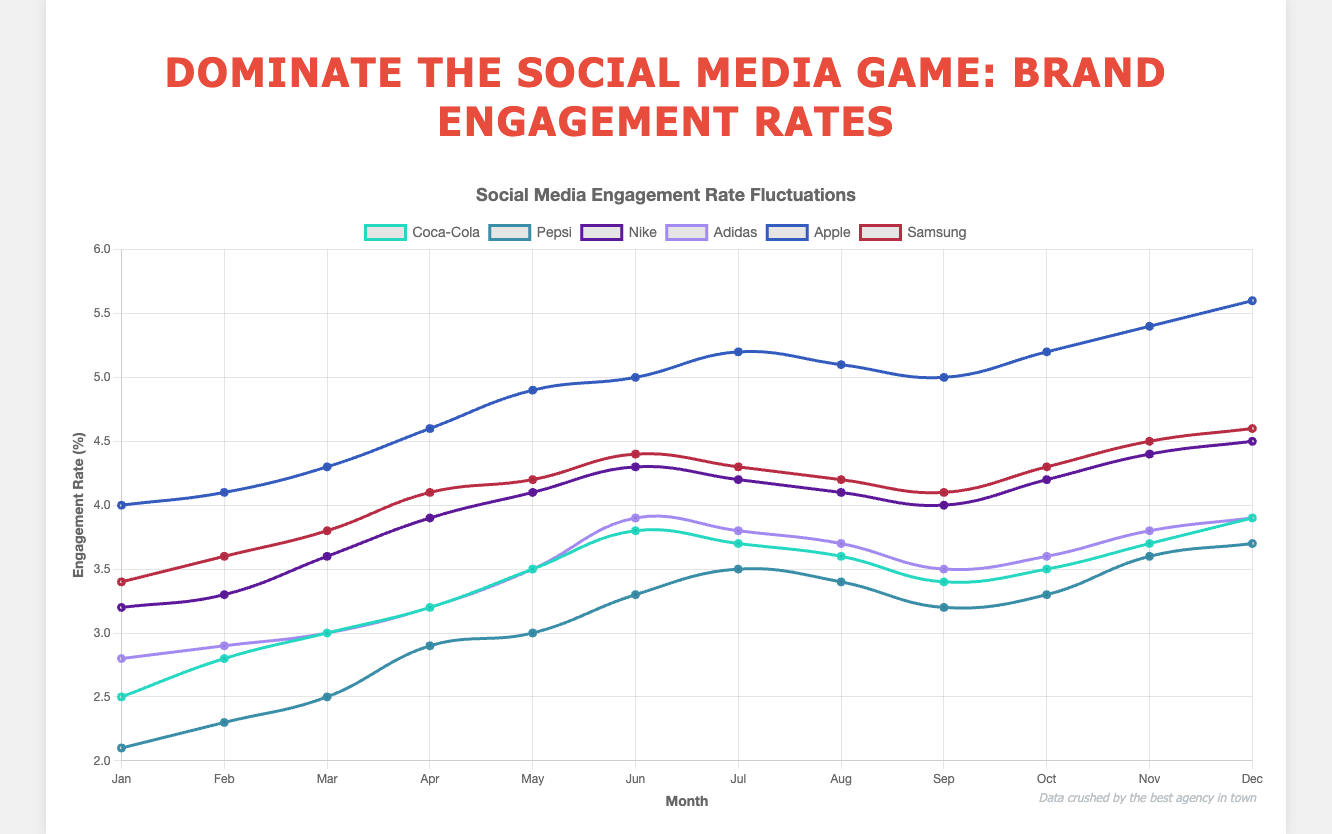Which brand has the highest engagement rate in December? In December, Apple has the highest engagement rate at 5.6%.
Answer: Apple How does Pepsi’s engagement rate in June compare to Coca-Cola’s engagement rate in June? Pepsi's engagement rate in June is 3.3%, while Coca-Cola's is 3.8%. So, Coca-Cola's rate is higher by 0.5%.
Answer: Coca-Cola is 0.5% higher Which brand has the most significant drop in engagement rate from July to August? By comparing the engagement rate drop from July to August across all brands, Nike shows a decrease from 4.2% to 4.1%, a drop of 0.1%. Pepsi drops from 3.5% to 3.4%, just 0.1%. Coca-Cola drops from 3.7% to 3.6%, also a 0.1% drop. Therefore, no brand has a significant drop; all have minor drops.
Answer: No significant drop What is the average engagement rate for Adidas over the year? Summing up the engagement rates for Adidas (2.8 + 2.9 + 3.0 + 3.2 + 3.5 + 3.9 + 3.8 + 3.7 + 3.5 + 3.6 + 3.8 + 3.9) gives 41.6%. Divided by 12 months, the average rate is approximately 3.47%.
Answer: 3.47% Which months does Apple exhibit an increasing engagement rate? Apple's engagement rate increases steadily every month from January (4.0) to December (5.6) without any decreases in any month.
Answer: All months What is Coca-Cola's engagement rate in March as a percentage of Nike's engagement rate in March? Coca-Cola's engagement rate in March is 3.0%, and Nike's is 3.6%. The percentage is (3.0/3.6) * 100 = 83.33%.
Answer: 83.33% How much higher is Samsung’s engagement rate in June compared to February? Samsung's engagement rate in June is 4.4%, while in February it is 3.6%. The difference is 4.4% - 3.6% = 0.8%.
Answer: 0.8% Which brand had the most stable engagement rate throughout the year? We calculate the variance for each brand's engagement rates. The brand with the lowest variance has the most stable rate. Apple’s rate varies between 4.0 to 5.6, while Pepsi varies between 2.1 to 3.7. Adidas and Coca-Cola have slight fluctuations. By visual inspection, Pepsi shows relatively stable engagement rates with minor differences month to month.
Answer: Pepsi 